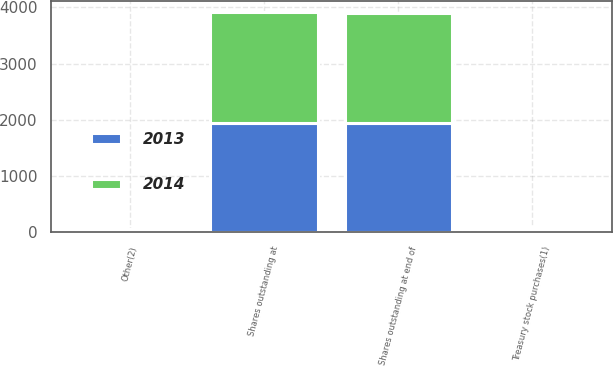Convert chart. <chart><loc_0><loc_0><loc_500><loc_500><stacked_bar_chart><ecel><fcel>Shares outstanding at<fcel>Treasury stock purchases(1)<fcel>Other(2)<fcel>Shares outstanding at end of<nl><fcel>2013<fcel>1945<fcel>46<fcel>52<fcel>1951<nl><fcel>2014<fcel>1974<fcel>27<fcel>2<fcel>1945<nl></chart> 